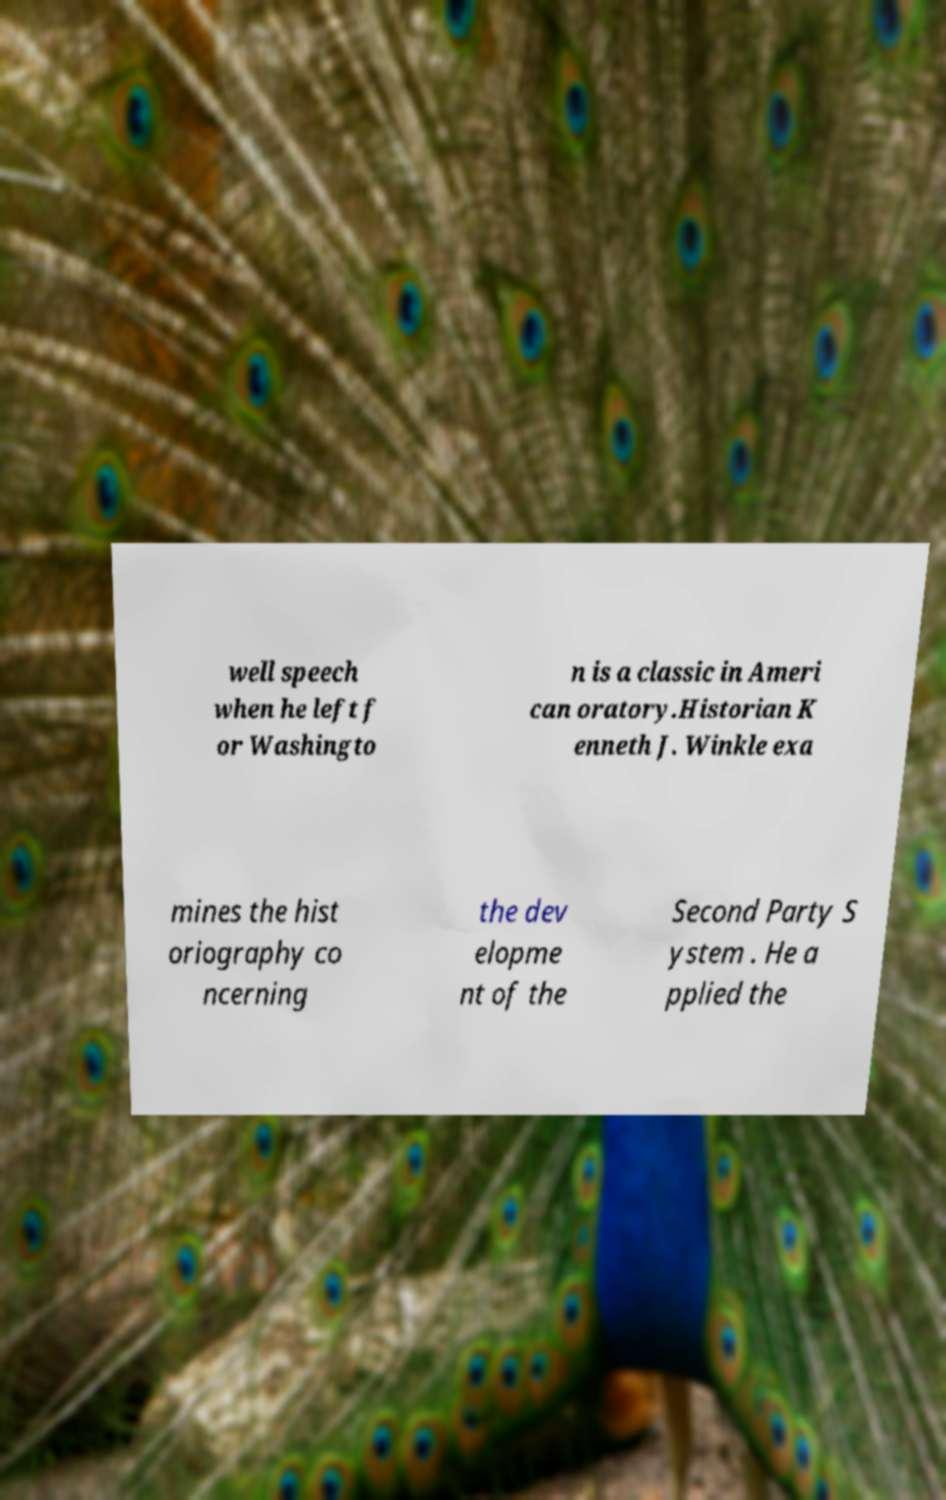Could you assist in decoding the text presented in this image and type it out clearly? well speech when he left f or Washingto n is a classic in Ameri can oratory.Historian K enneth J. Winkle exa mines the hist oriography co ncerning the dev elopme nt of the Second Party S ystem . He a pplied the 